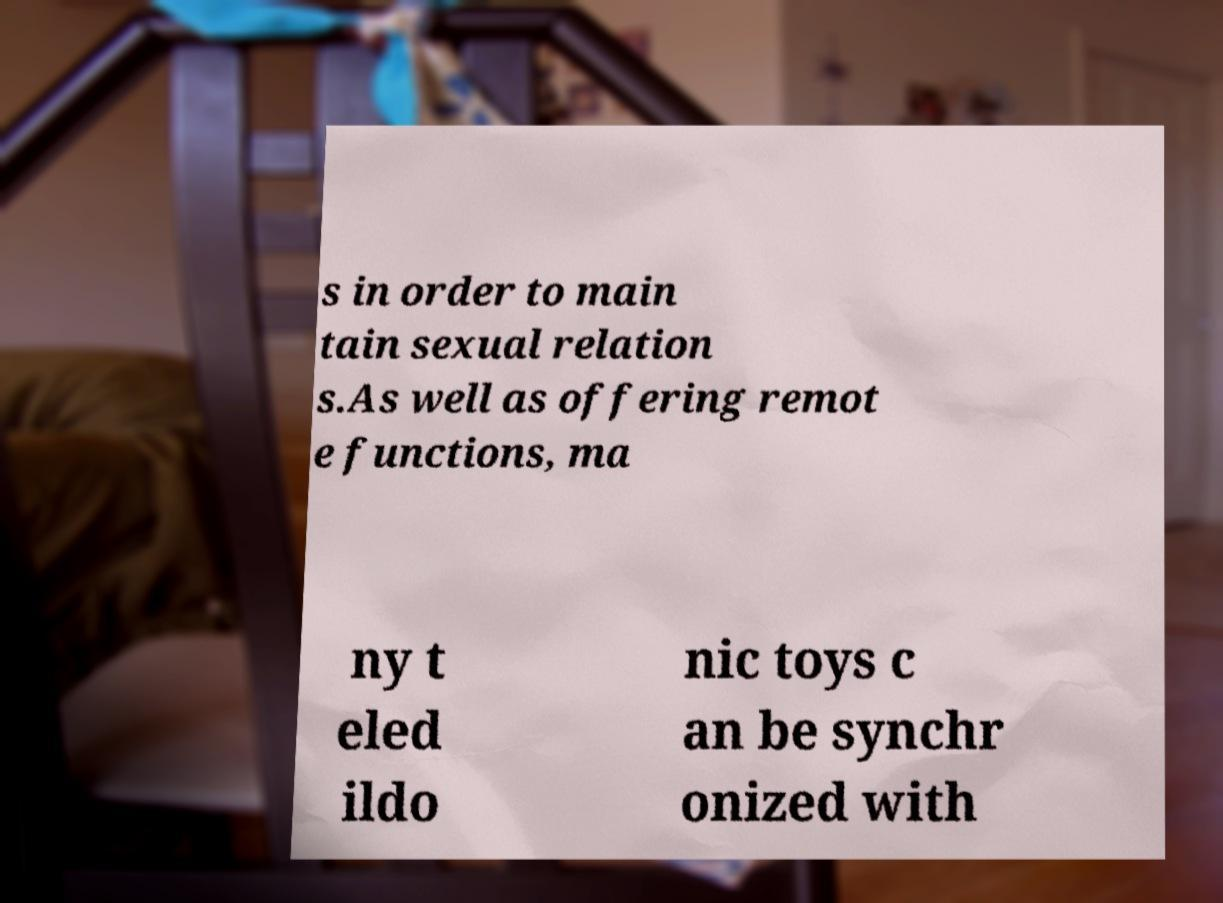I need the written content from this picture converted into text. Can you do that? s in order to main tain sexual relation s.As well as offering remot e functions, ma ny t eled ildo nic toys c an be synchr onized with 